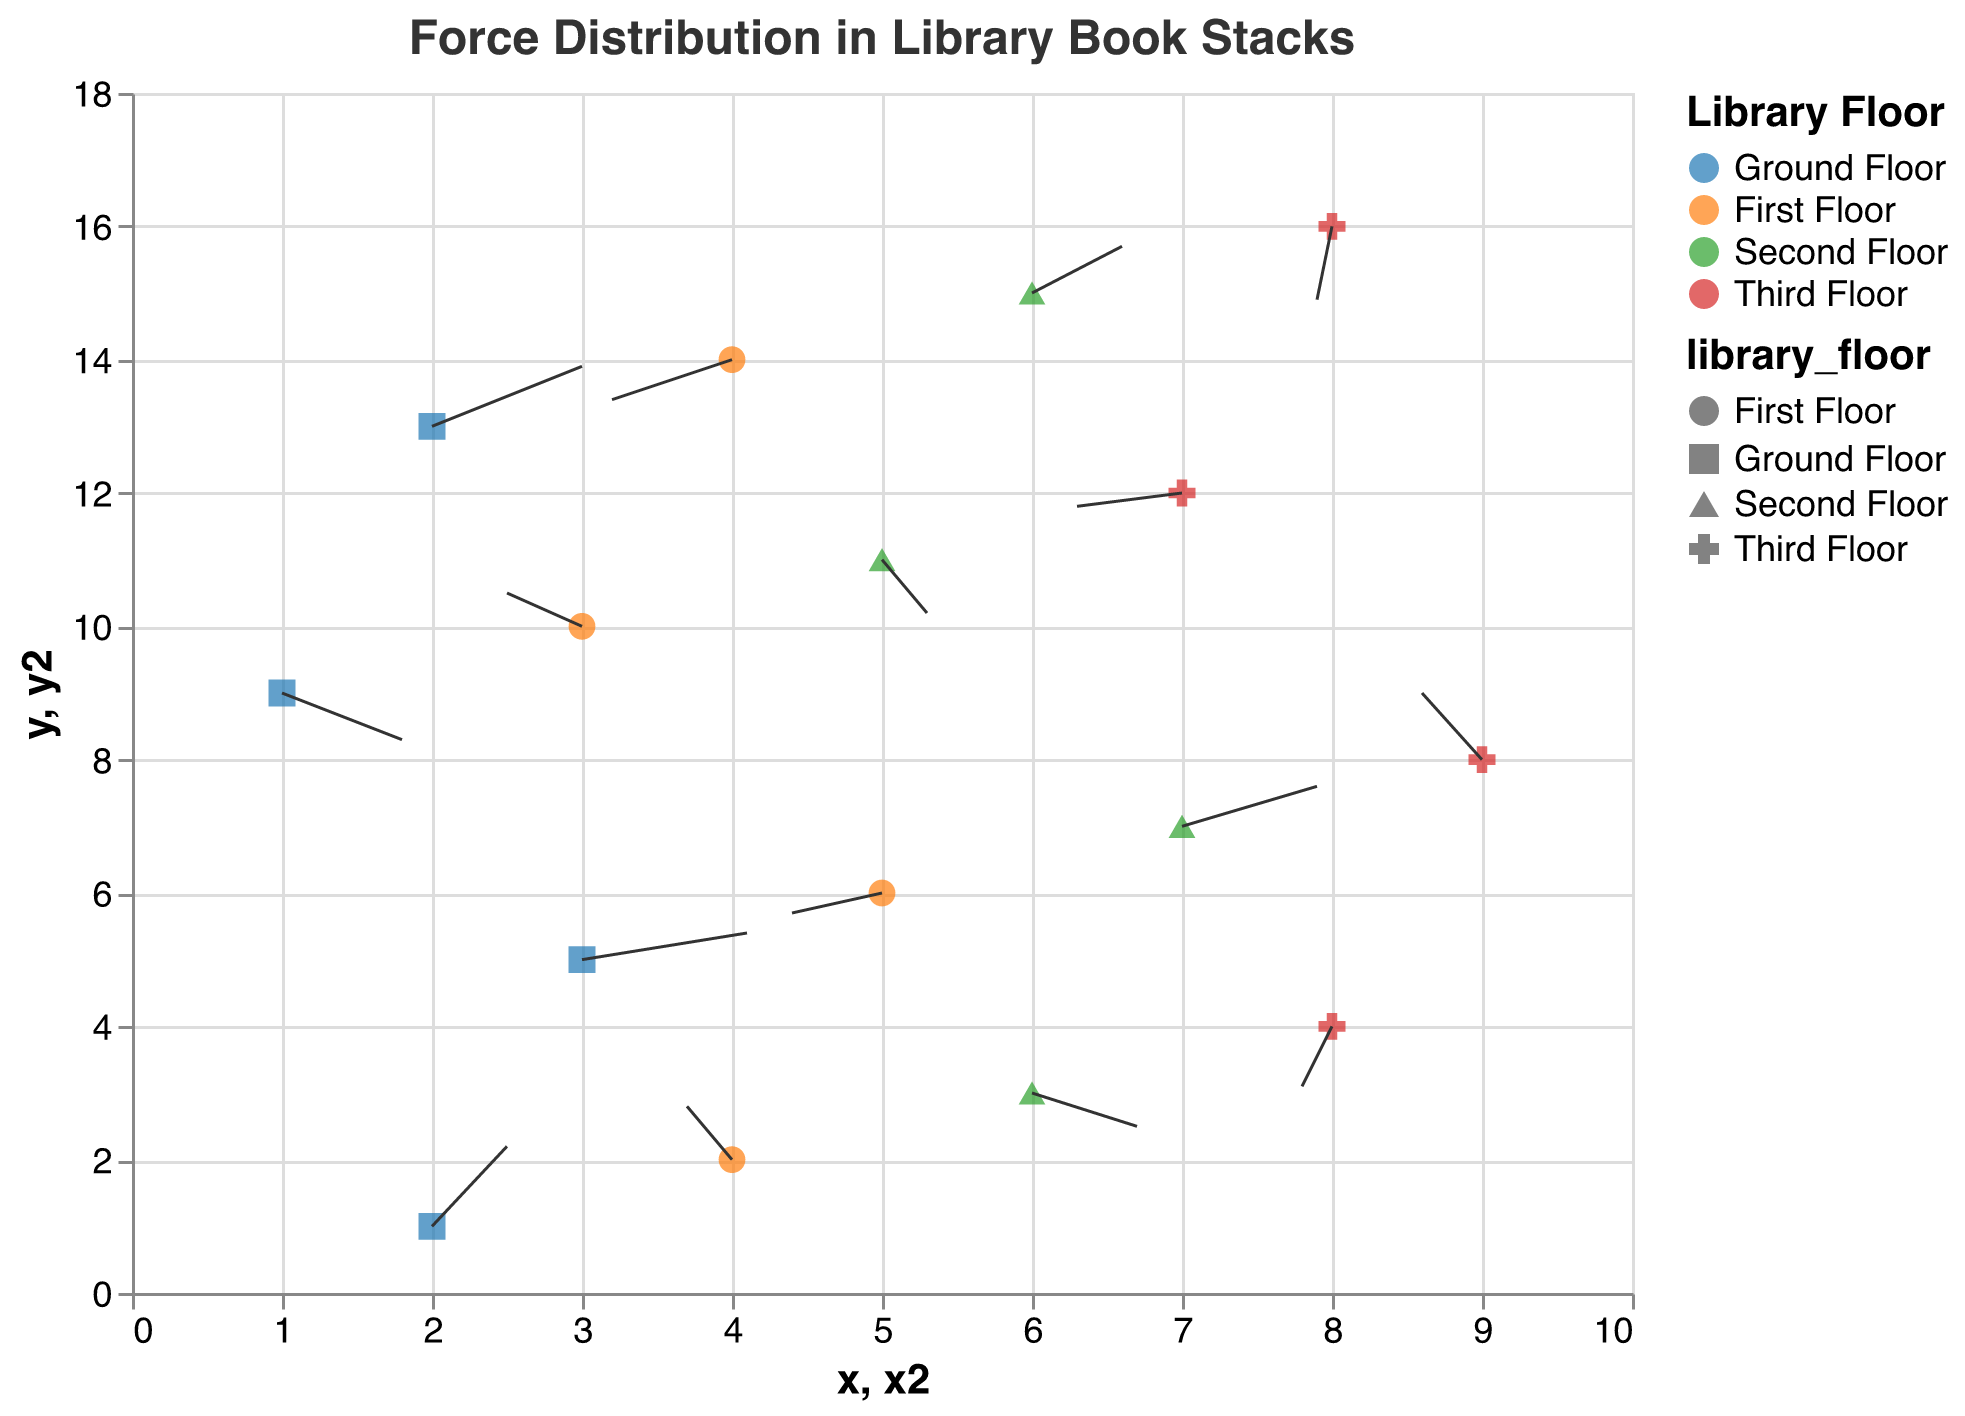What is the title of the plot? The title is at the top of the plot. It reads "Force Distribution in Library Book Stacks".
Answer: Force Distribution in Library Book Stacks How many different floors are represented in the plot? The legend on the right side of the plot indicates the different categories. There are four distinct colors corresponding to "Ground Floor", "First Floor", "Second Floor", and "Third Floor".
Answer: Four Which library floor has the most vectors pointing in a direction with positive u (rightward direction)? By checking the direction of the vectors, the Ground Floor has three vectors (points at x=2, y=1; x=3, y=5; x=2, y=13) with positive u values. Other floors have fewer vectors with positive u.
Answer: Ground Floor What is the direction of the vector at coordinates (4, 2)? The vector at (4, 2) has components u = -0.3 and v = 0.8, meaning it points to the left and slightly upwards.
Answer: Left and upwards Which floor has the vector with the largest magnitude? Magnitude is calculated as the square root of (u^2 + v^2). The vector at coordinates (2, 13) with u = 1.0 and v = 0.9 has the largest magnitude √(1.0^2 + 0.9^2) ≈ 1.34, and it's on the Ground Floor.
Answer: Ground Floor On which floor is the vector pointing straight downwards the longest? A vector points straight downwards if u=0. Checking vectors with negative v values, the vector on the Third Floor at (8, 16) with v=-1.1 has the largest downward y-component magnitude.
Answer: Third Floor How many vectors on the Third Floor point downwards? The vectors on the Third Floor at (8, 4; 7, 12; 8, 16) have negative v-components indicating they point downwards.
Answer: Three 